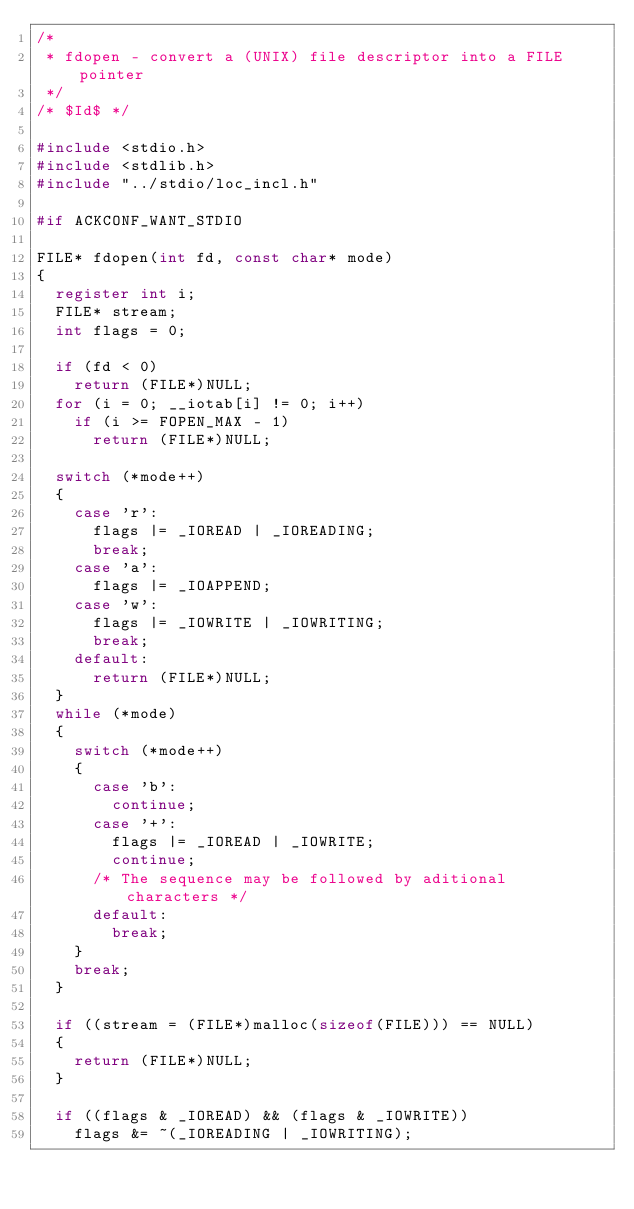Convert code to text. <code><loc_0><loc_0><loc_500><loc_500><_C_>/*
 * fdopen - convert a (UNIX) file descriptor into a FILE pointer
 */
/* $Id$ */

#include <stdio.h>
#include <stdlib.h>
#include "../stdio/loc_incl.h"

#if ACKCONF_WANT_STDIO

FILE* fdopen(int fd, const char* mode)
{
	register int i;
	FILE* stream;
	int flags = 0;

	if (fd < 0)
		return (FILE*)NULL;
	for (i = 0; __iotab[i] != 0; i++)
		if (i >= FOPEN_MAX - 1)
			return (FILE*)NULL;

	switch (*mode++)
	{
		case 'r':
			flags |= _IOREAD | _IOREADING;
			break;
		case 'a':
			flags |= _IOAPPEND;
		case 'w':
			flags |= _IOWRITE | _IOWRITING;
			break;
		default:
			return (FILE*)NULL;
	}
	while (*mode)
	{
		switch (*mode++)
		{
			case 'b':
				continue;
			case '+':
				flags |= _IOREAD | _IOWRITE;
				continue;
			/* The sequence may be followed by aditional characters */
			default:
				break;
		}
		break;
	}

	if ((stream = (FILE*)malloc(sizeof(FILE))) == NULL)
	{
		return (FILE*)NULL;
	}

	if ((flags & _IOREAD) && (flags & _IOWRITE))
		flags &= ~(_IOREADING | _IOWRITING);
</code> 